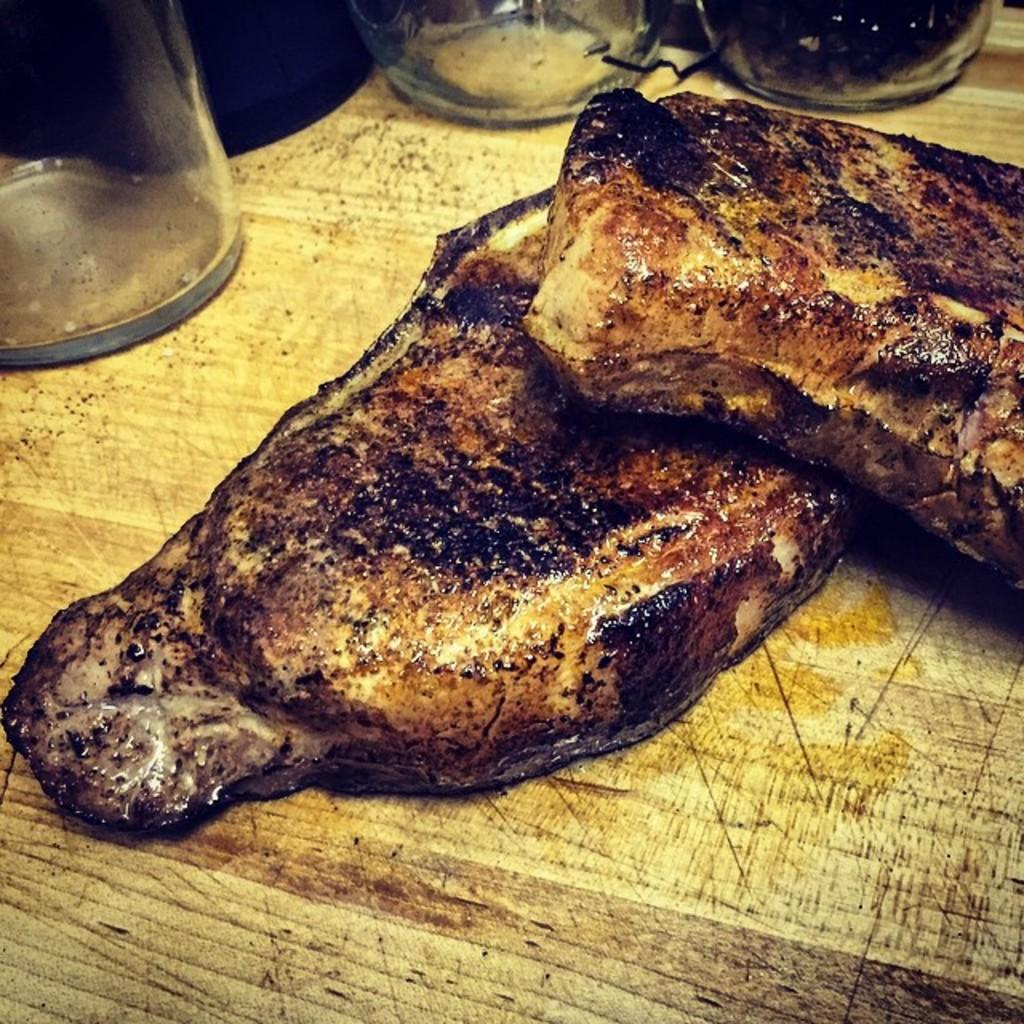What is present in the image related to food? There is food in the image. What other items can be seen in the image besides food? There is a group of glasses in the image. Where are the food and glasses located in the image? The food and glasses are placed on a table. Can you tell me how many owls are sitting on the table in the image? There are no owls present in the image; it only features food and glasses on a table. What type of care is being provided to the food in the image? There is no indication of any care being provided to the food in the image. 